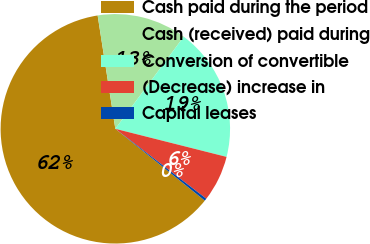<chart> <loc_0><loc_0><loc_500><loc_500><pie_chart><fcel>Cash paid during the period<fcel>Cash (received) paid during<fcel>Conversion of convertible<fcel>(Decrease) increase in<fcel>Capital leases<nl><fcel>61.77%<fcel>12.63%<fcel>18.77%<fcel>6.49%<fcel>0.34%<nl></chart> 